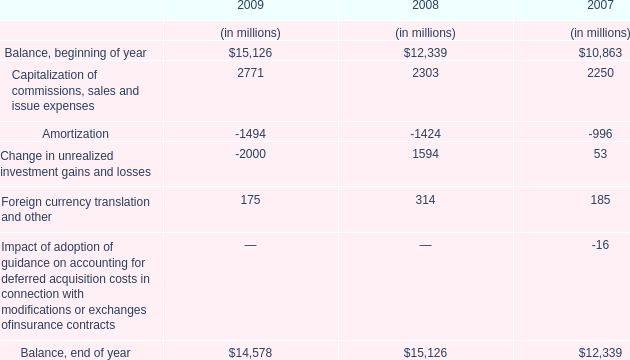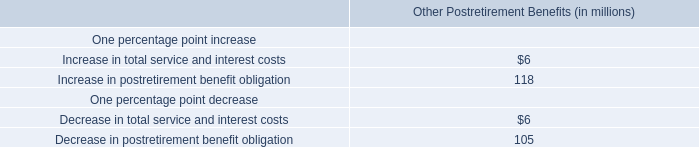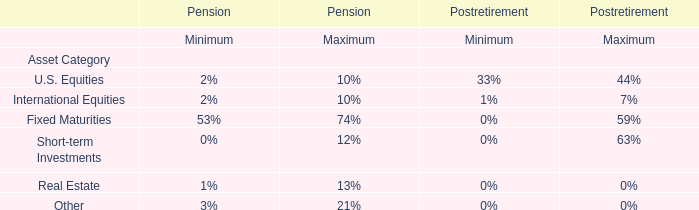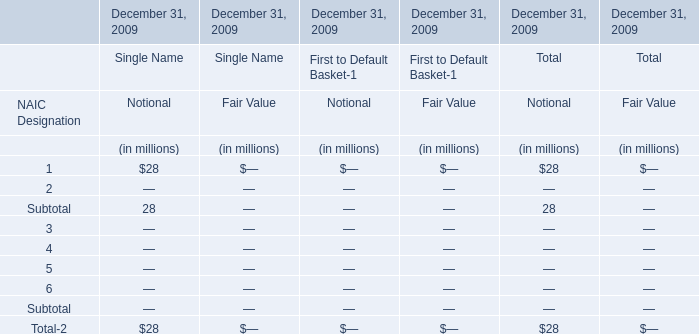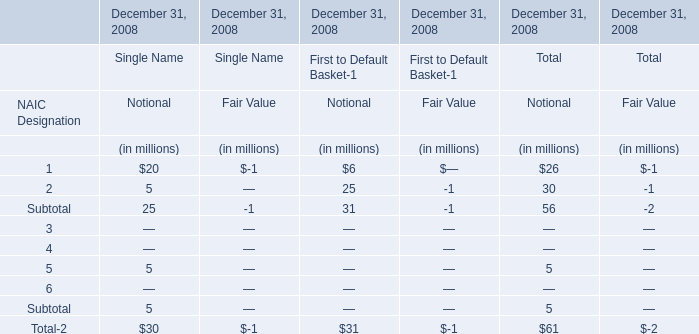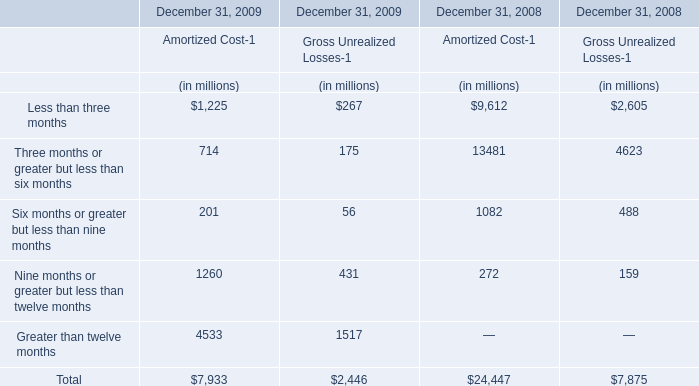What's the average of Amortized Cost-1 in 2009? (in million) 
Computations: (7933 / 5)
Answer: 1586.6. 